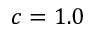<formula> <loc_0><loc_0><loc_500><loc_500>c = 1 . 0</formula> 